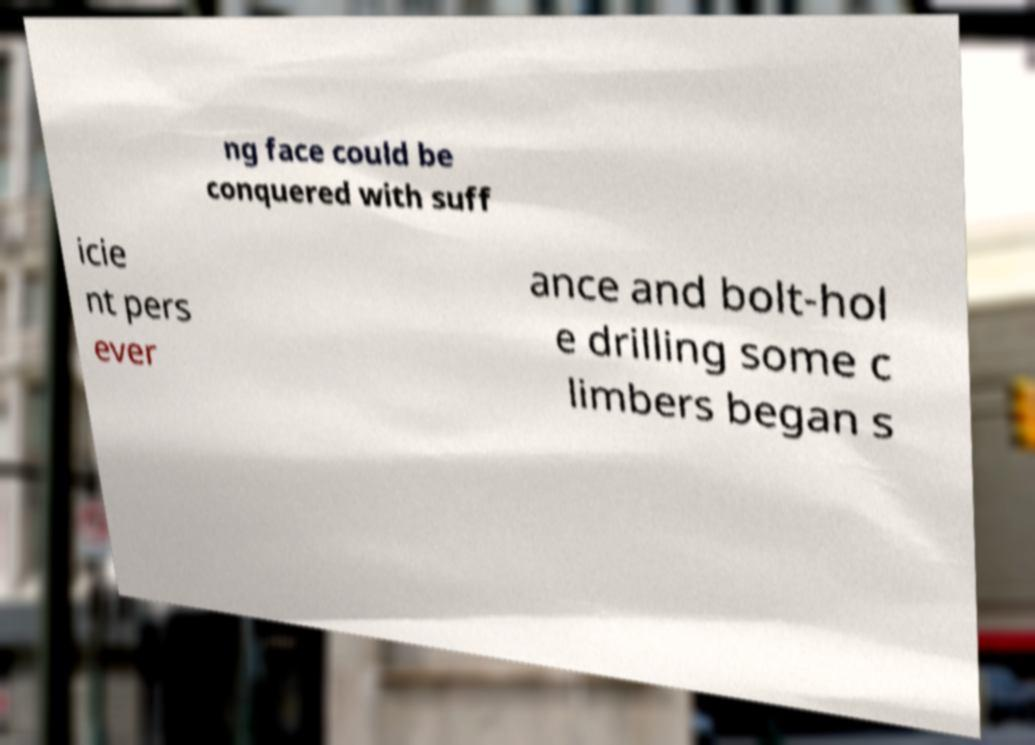Can you read and provide the text displayed in the image?This photo seems to have some interesting text. Can you extract and type it out for me? ng face could be conquered with suff icie nt pers ever ance and bolt-hol e drilling some c limbers began s 